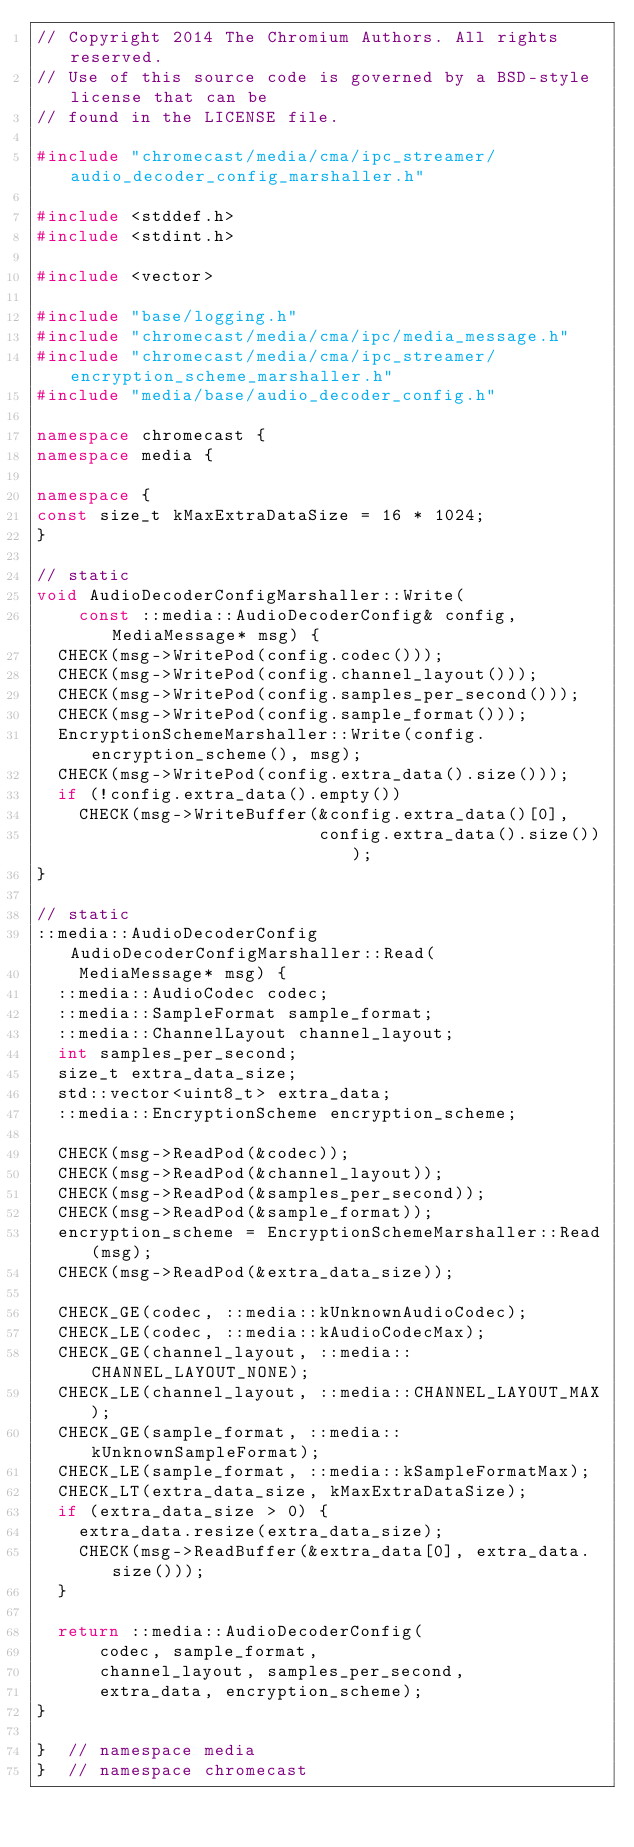<code> <loc_0><loc_0><loc_500><loc_500><_C++_>// Copyright 2014 The Chromium Authors. All rights reserved.
// Use of this source code is governed by a BSD-style license that can be
// found in the LICENSE file.

#include "chromecast/media/cma/ipc_streamer/audio_decoder_config_marshaller.h"

#include <stddef.h>
#include <stdint.h>

#include <vector>

#include "base/logging.h"
#include "chromecast/media/cma/ipc/media_message.h"
#include "chromecast/media/cma/ipc_streamer/encryption_scheme_marshaller.h"
#include "media/base/audio_decoder_config.h"

namespace chromecast {
namespace media {

namespace {
const size_t kMaxExtraDataSize = 16 * 1024;
}

// static
void AudioDecoderConfigMarshaller::Write(
    const ::media::AudioDecoderConfig& config, MediaMessage* msg) {
  CHECK(msg->WritePod(config.codec()));
  CHECK(msg->WritePod(config.channel_layout()));
  CHECK(msg->WritePod(config.samples_per_second()));
  CHECK(msg->WritePod(config.sample_format()));
  EncryptionSchemeMarshaller::Write(config.encryption_scheme(), msg);
  CHECK(msg->WritePod(config.extra_data().size()));
  if (!config.extra_data().empty())
    CHECK(msg->WriteBuffer(&config.extra_data()[0],
                           config.extra_data().size()));
}

// static
::media::AudioDecoderConfig AudioDecoderConfigMarshaller::Read(
    MediaMessage* msg) {
  ::media::AudioCodec codec;
  ::media::SampleFormat sample_format;
  ::media::ChannelLayout channel_layout;
  int samples_per_second;
  size_t extra_data_size;
  std::vector<uint8_t> extra_data;
  ::media::EncryptionScheme encryption_scheme;

  CHECK(msg->ReadPod(&codec));
  CHECK(msg->ReadPod(&channel_layout));
  CHECK(msg->ReadPod(&samples_per_second));
  CHECK(msg->ReadPod(&sample_format));
  encryption_scheme = EncryptionSchemeMarshaller::Read(msg);
  CHECK(msg->ReadPod(&extra_data_size));

  CHECK_GE(codec, ::media::kUnknownAudioCodec);
  CHECK_LE(codec, ::media::kAudioCodecMax);
  CHECK_GE(channel_layout, ::media::CHANNEL_LAYOUT_NONE);
  CHECK_LE(channel_layout, ::media::CHANNEL_LAYOUT_MAX);
  CHECK_GE(sample_format, ::media::kUnknownSampleFormat);
  CHECK_LE(sample_format, ::media::kSampleFormatMax);
  CHECK_LT(extra_data_size, kMaxExtraDataSize);
  if (extra_data_size > 0) {
    extra_data.resize(extra_data_size);
    CHECK(msg->ReadBuffer(&extra_data[0], extra_data.size()));
  }

  return ::media::AudioDecoderConfig(
      codec, sample_format,
      channel_layout, samples_per_second,
      extra_data, encryption_scheme);
}

}  // namespace media
}  // namespace chromecast
</code> 